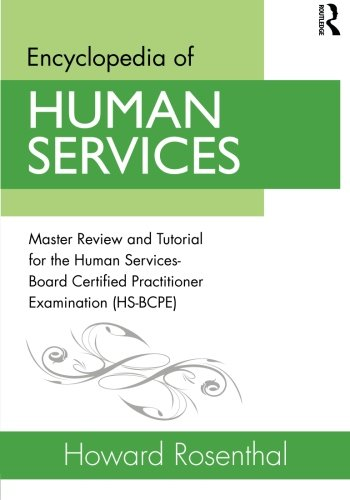What is the genre of this book? While essentially categorized under Politics & Social Sciences, this book specifically serves as an educational resource in the professional development and certification preparation niche for human service practitioners. 